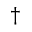<formula> <loc_0><loc_0><loc_500><loc_500>\dagger</formula> 